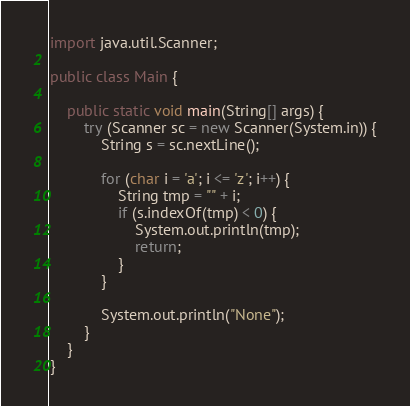<code> <loc_0><loc_0><loc_500><loc_500><_Java_>
import java.util.Scanner;

public class Main {

	public static void main(String[] args) {
		try (Scanner sc = new Scanner(System.in)) {
			String s = sc.nextLine();

			for (char i = 'a'; i <= 'z'; i++) {
				String tmp = "" + i;
				if (s.indexOf(tmp) < 0) {
					System.out.println(tmp);
					return;
				}
			}

			System.out.println("None");
		}
	}
}
</code> 